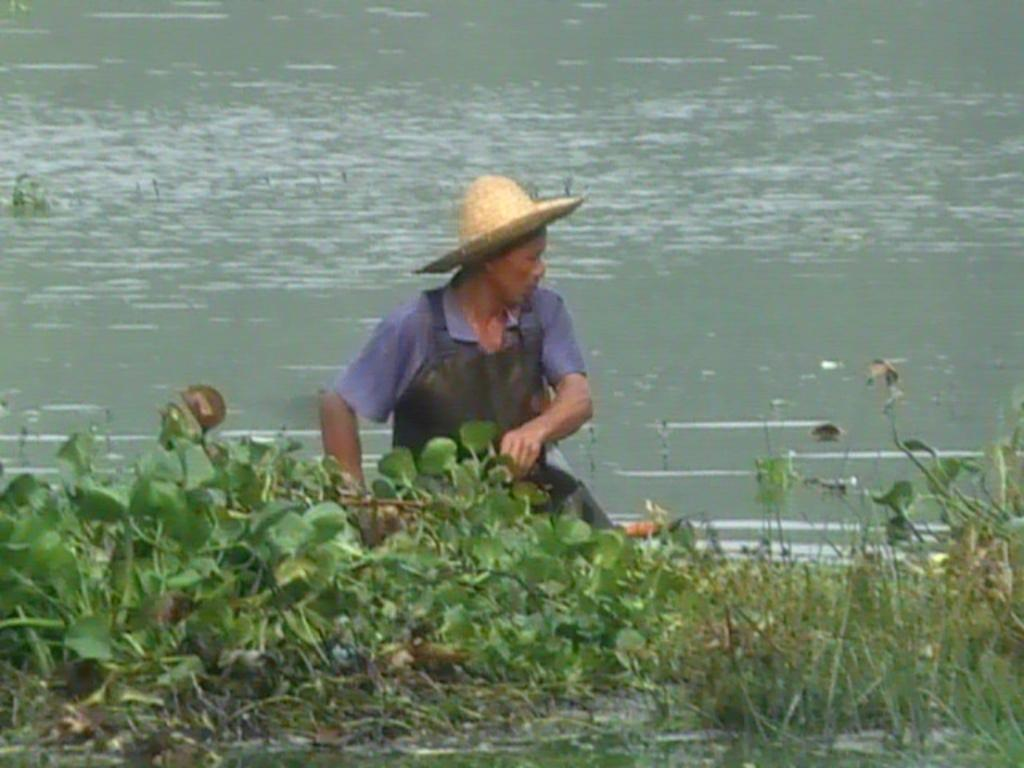Who or what is present in the image? There is a person in the image. What is in front of the person? There are plants in front of the person. What can be seen in the background of the image? There is water visible in the background of the image. What type of trucks can be seen in the image? There are no trucks present in the image. Where is the person on vacation in the image? The image does not provide any information about the person being on vacation. 